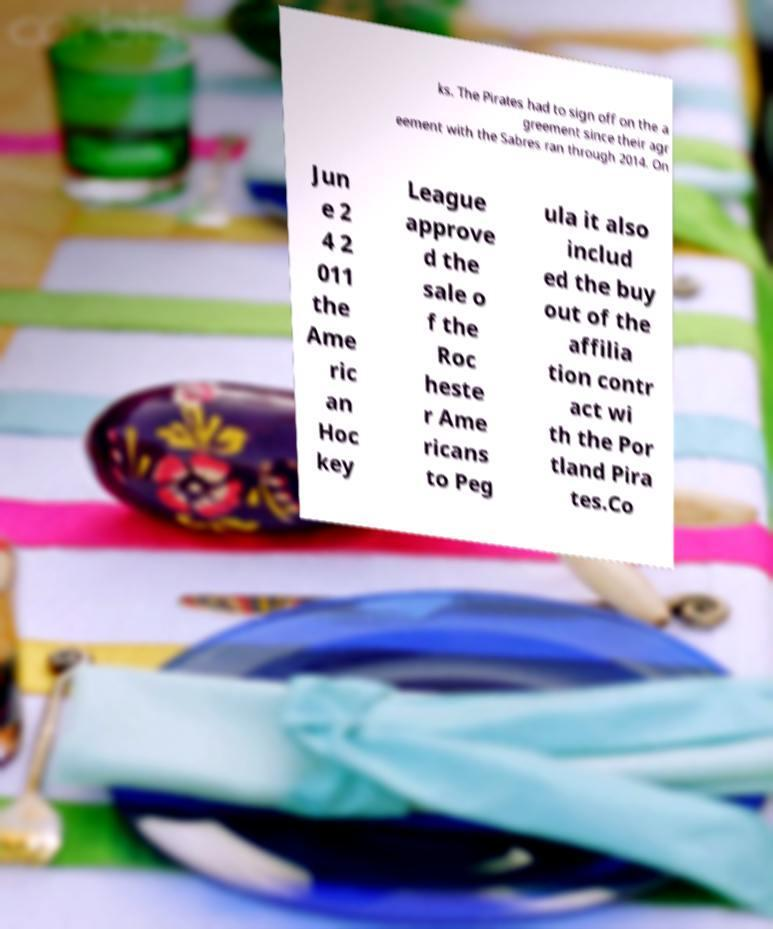There's text embedded in this image that I need extracted. Can you transcribe it verbatim? ks. The Pirates had to sign off on the a greement since their agr eement with the Sabres ran through 2014. On Jun e 2 4 2 011 the Ame ric an Hoc key League approve d the sale o f the Roc heste r Ame ricans to Peg ula it also includ ed the buy out of the affilia tion contr act wi th the Por tland Pira tes.Co 